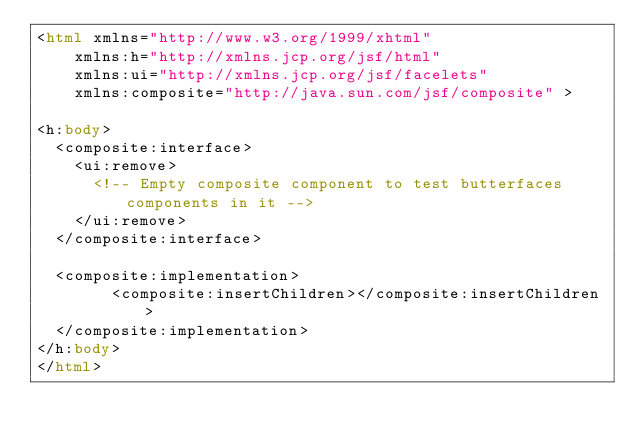<code> <loc_0><loc_0><loc_500><loc_500><_HTML_><html xmlns="http://www.w3.org/1999/xhtml" 
	  xmlns:h="http://xmlns.jcp.org/jsf/html"
	  xmlns:ui="http://xmlns.jcp.org/jsf/facelets"
	  xmlns:composite="http://java.sun.com/jsf/composite" >

<h:body>
	<composite:interface>
		<ui:remove>
			<!-- Empty composite component to test butterfaces components in it -->
		</ui:remove>
	</composite:interface>

	<composite:implementation>
        <composite:insertChildren></composite:insertChildren>
	</composite:implementation>
</h:body>
</html></code> 